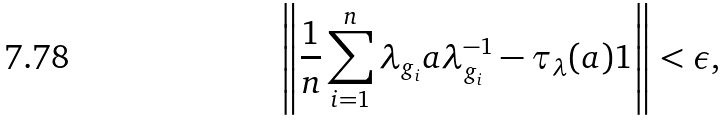<formula> <loc_0><loc_0><loc_500><loc_500>\left \| \frac { 1 } { n } \sum _ { i = 1 } ^ { n } \lambda _ { g _ { i } } a \lambda _ { g _ { i } } ^ { - 1 } - \tau _ { \lambda } ( a ) 1 \right \| < \epsilon ,</formula> 